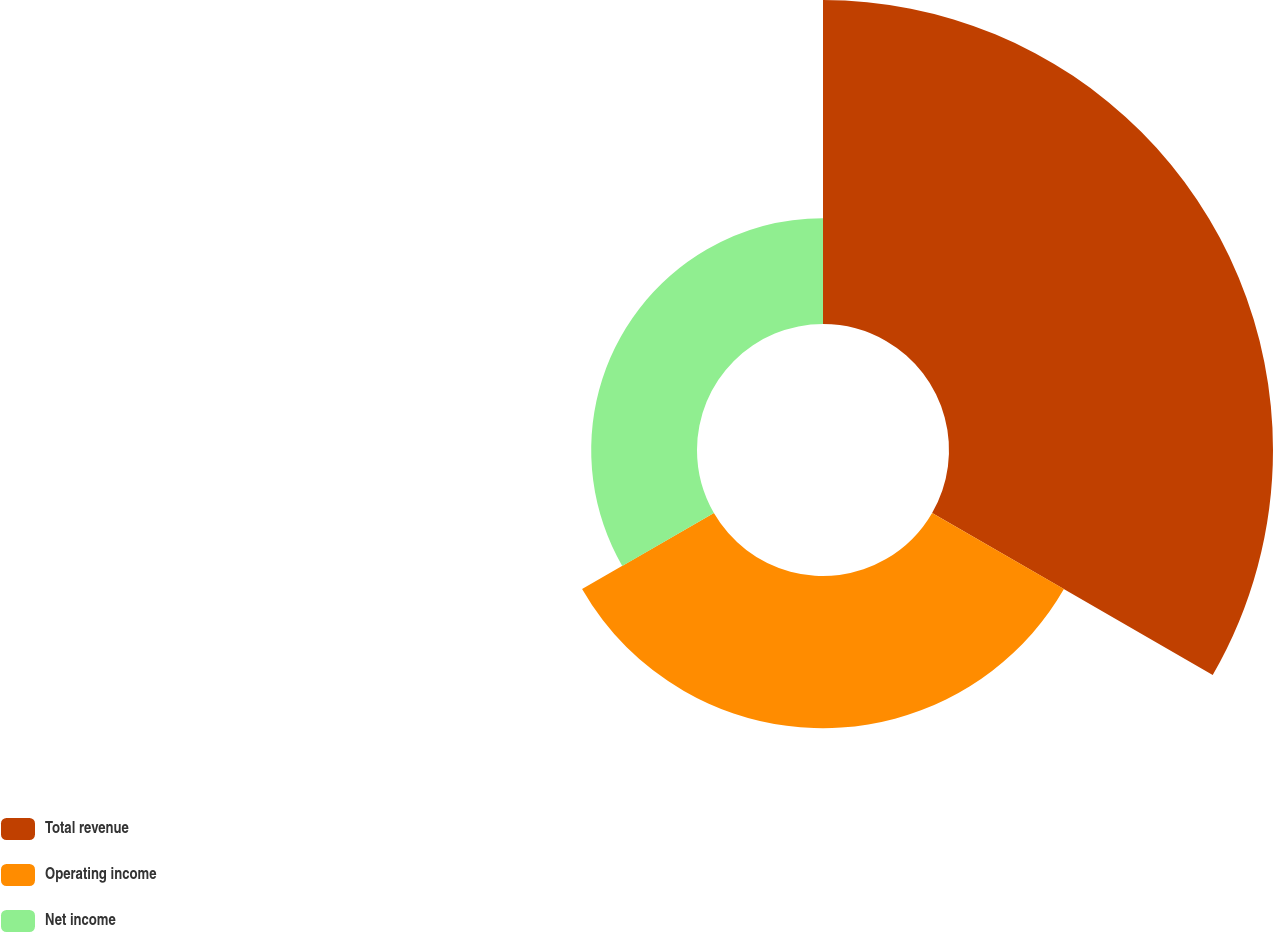Convert chart to OTSL. <chart><loc_0><loc_0><loc_500><loc_500><pie_chart><fcel>Total revenue<fcel>Operating income<fcel>Net income<nl><fcel>55.67%<fcel>26.15%<fcel>18.18%<nl></chart> 